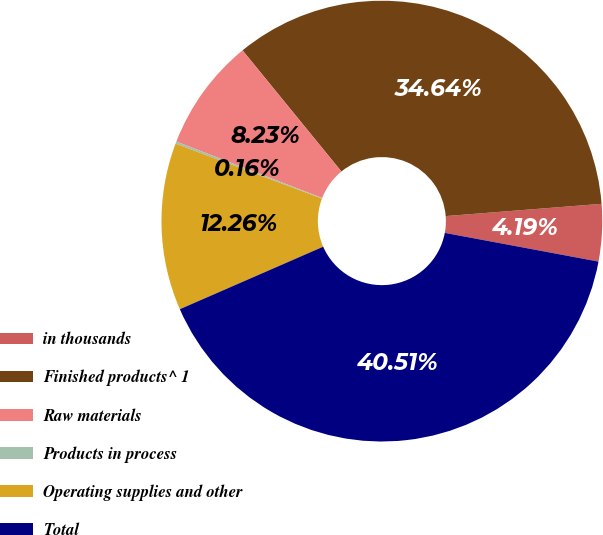Convert chart. <chart><loc_0><loc_0><loc_500><loc_500><pie_chart><fcel>in thousands<fcel>Finished products^ 1<fcel>Raw materials<fcel>Products in process<fcel>Operating supplies and other<fcel>Total<nl><fcel>4.19%<fcel>34.64%<fcel>8.23%<fcel>0.16%<fcel>12.26%<fcel>40.51%<nl></chart> 